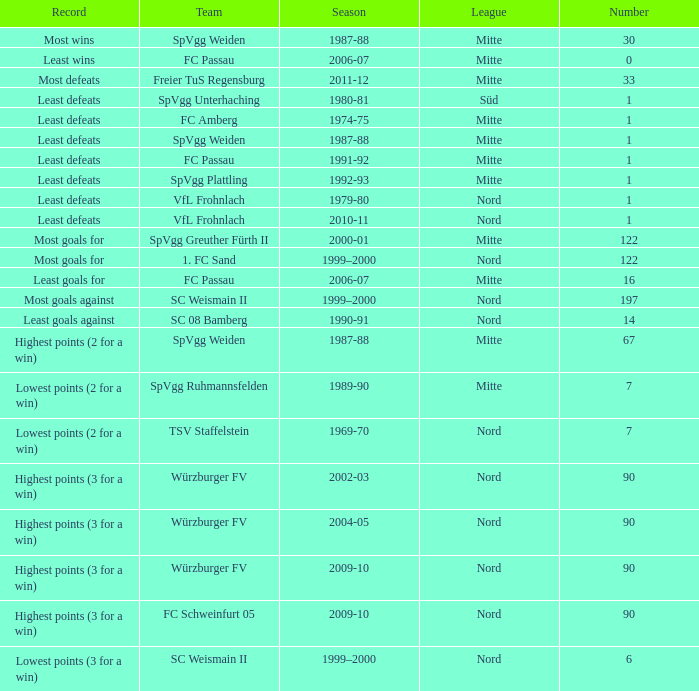What team has 2000-01 as the season? SpVgg Greuther Fürth II. 